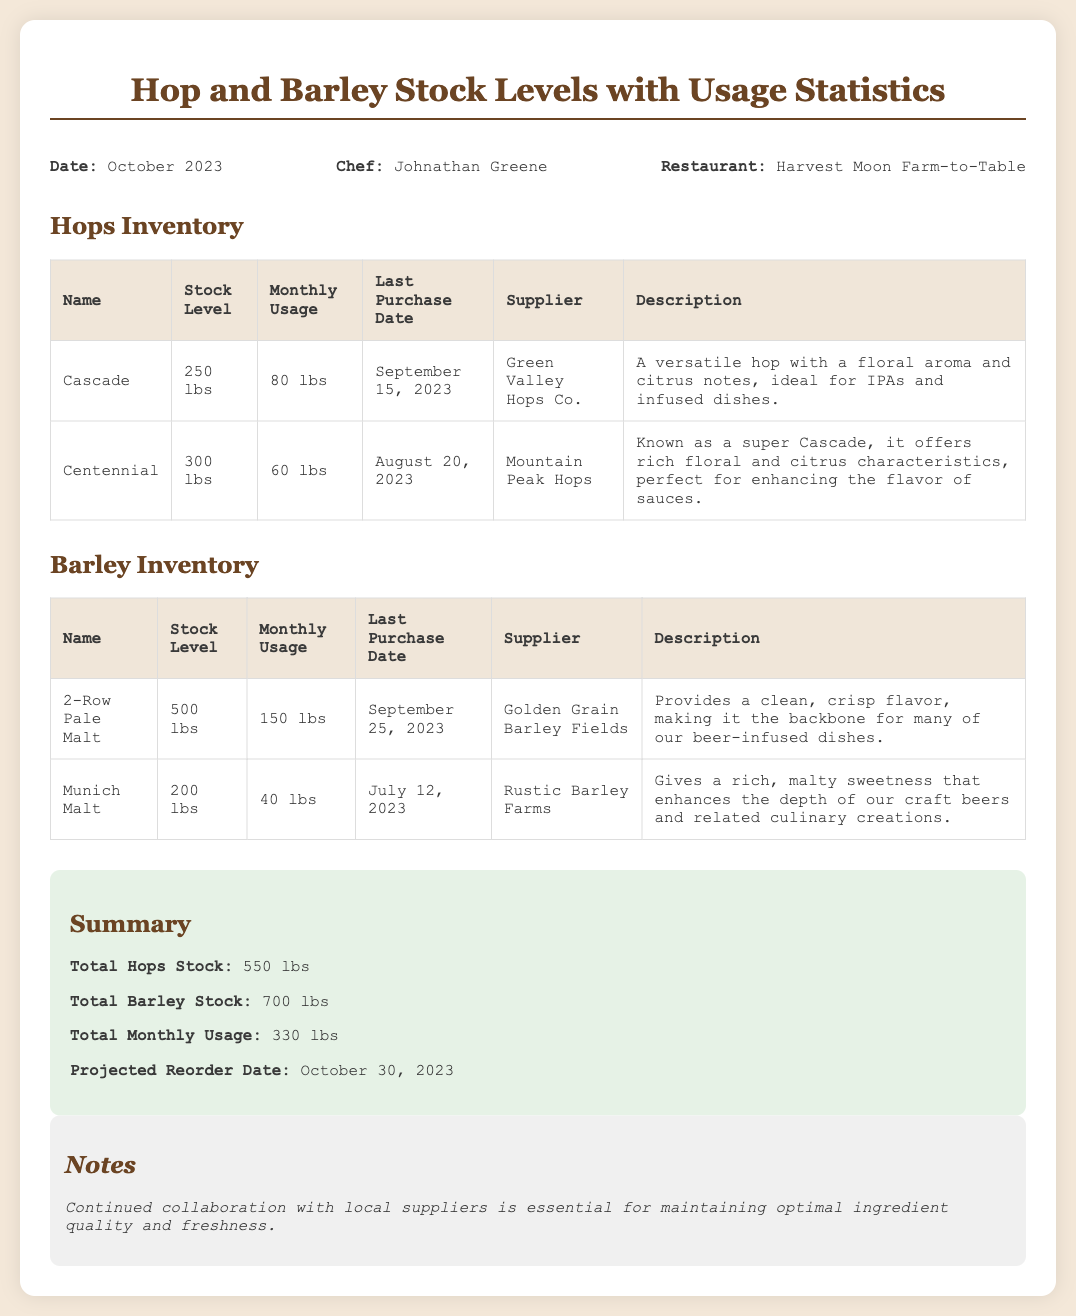What is the stock level of Cascade hops? The stock level of Cascade hops is stated in the Hops Inventory section of the document.
Answer: 250 lbs What is the total barley stock? The total barley stock is provided in the Summary section of the document.
Answer: 700 lbs When was the last purchase date for Munich Malt? The last purchase date for Munich Malt is recorded in the Barley Inventory table.
Answer: July 12, 2023 Who is the supplier for 2-Row Pale Malt? The supplier for 2-Row Pale Malt is listed in the Barley Inventory section.
Answer: Golden Grain Barley Fields What is the monthly usage of Centennial hops? The monthly usage of Centennial hops is indicated in the Hops Inventory table.
Answer: 60 lbs What is the projected reorder date? The projected reorder date is specified in the Summary section.
Answer: October 30, 2023 Which hop is known as a super Cascade? The document explains which hop is known as a super Cascade in the Hops Inventory.
Answer: Centennial How much total monthly usage is there for hops and barley combined? The total monthly usage is calculated from the individual monthly usage listed in the corresponding inventory tables.
Answer: 330 lbs 